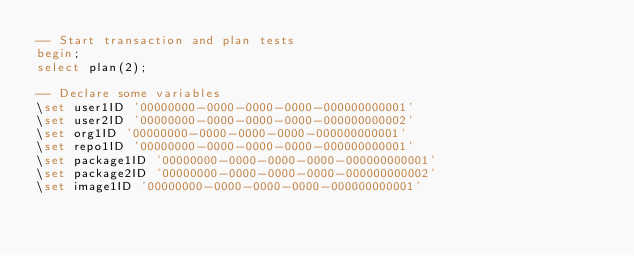Convert code to text. <code><loc_0><loc_0><loc_500><loc_500><_SQL_>-- Start transaction and plan tests
begin;
select plan(2);

-- Declare some variables
\set user1ID '00000000-0000-0000-0000-000000000001'
\set user2ID '00000000-0000-0000-0000-000000000002'
\set org1ID '00000000-0000-0000-0000-000000000001'
\set repo1ID '00000000-0000-0000-0000-000000000001'
\set package1ID '00000000-0000-0000-0000-000000000001'
\set package2ID '00000000-0000-0000-0000-000000000002'
\set image1ID '00000000-0000-0000-0000-000000000001'</code> 